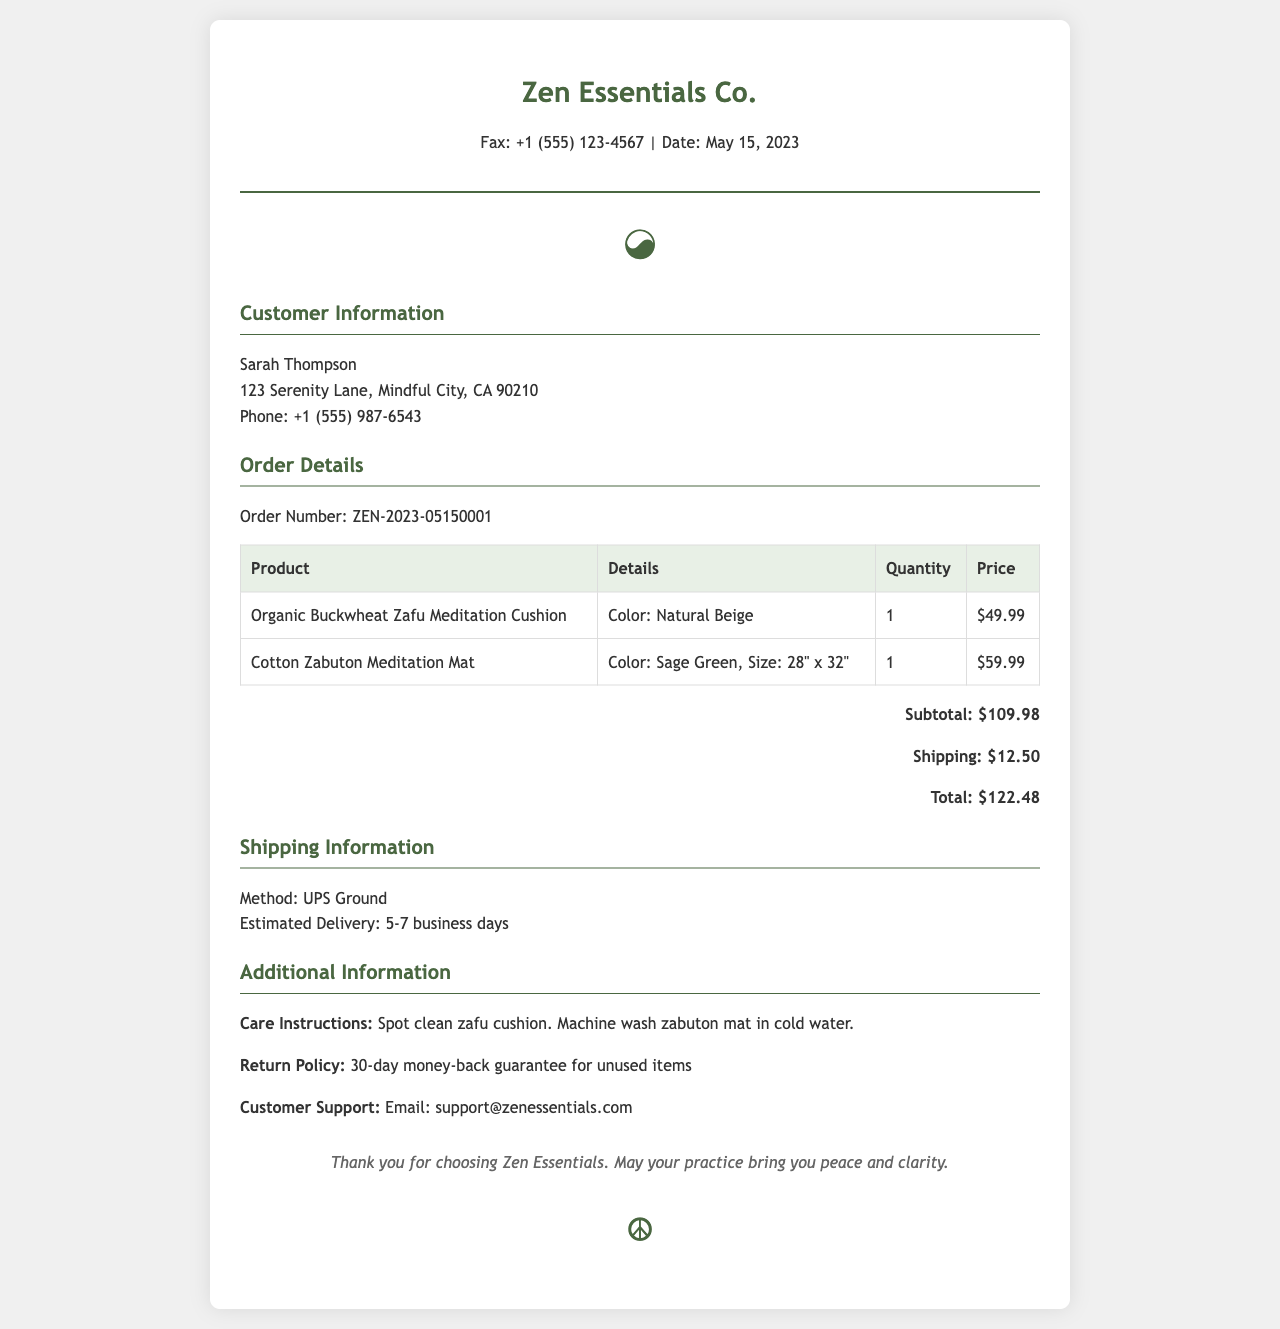What is the order number? The order number is a unique identifier for the order placed by the customer, which is ZEN-2023-05150001.
Answer: ZEN-2023-05150001 What is the price of the Zafu meditation cushion? The document lists the price of the Organic Buckwheat Zafu Meditation Cushion, which is $49.99.
Answer: $49.99 What is the estimated delivery time? The estimated delivery time is mentioned in the shipping information section, which states 5-7 business days.
Answer: 5-7 business days Who is the customer? The customer information section provides the name of the customer, which is Sarah Thompson.
Answer: Sarah Thompson What is the total cost including shipping? The total cost is calculated by summing the subtotal and shipping cost, which is $109.98 + $12.50 = $122.48.
Answer: $122.48 What color is the Zabuton meditation mat? The document specifies that the Cotton Zabuton Meditation Mat comes in Sage Green.
Answer: Sage Green What are the care instructions for the Zafu cushion? The care instructions section indicates that the Zafu cushion should be spot cleaned.
Answer: Spot clean What is the return policy? The document states that there is a 30-day money-back guarantee for unused items.
Answer: 30-day money-back guarantee What shipping method is used? The shipping information section indicates that UPS Ground is the shipping method selected for this order.
Answer: UPS Ground 